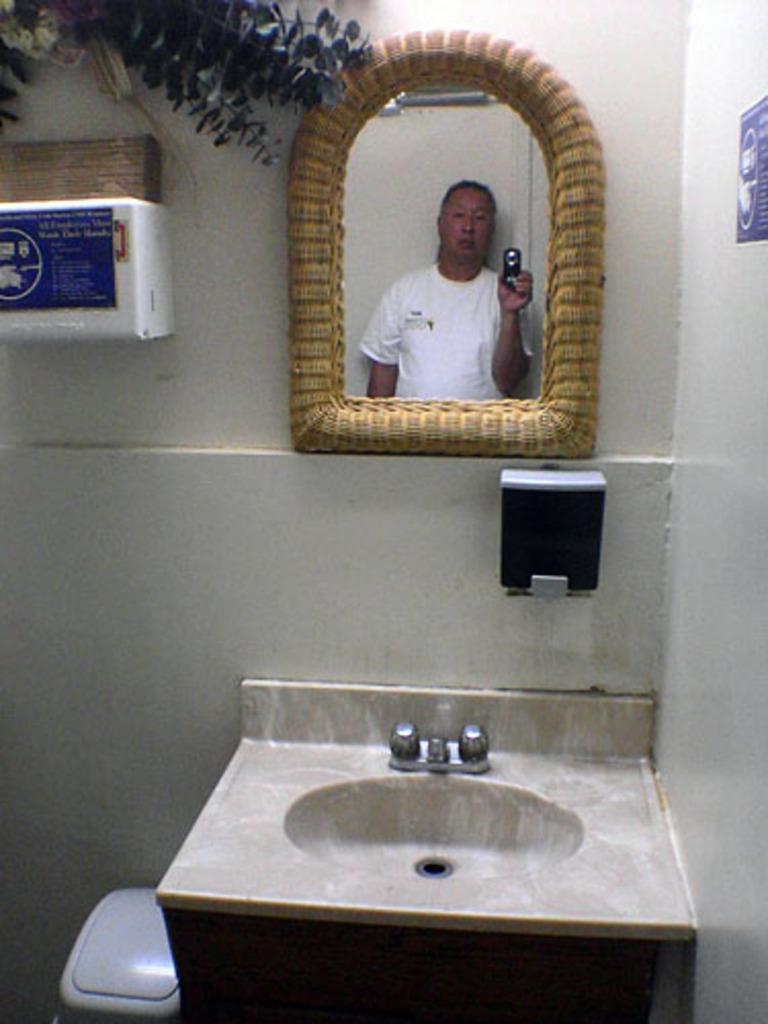Could you give a brief overview of what you see in this image? In this image in the front there is a wash basin and there is a mirror on the wall and in the mirror there is a reflection of the person holding a mobile phone and on the right side of the wall there is a poster with some text written on it and on the left side of the wash basin there is an object which is white in colour and on the wall there is an object which is white in colour and on the top there are leaves. 